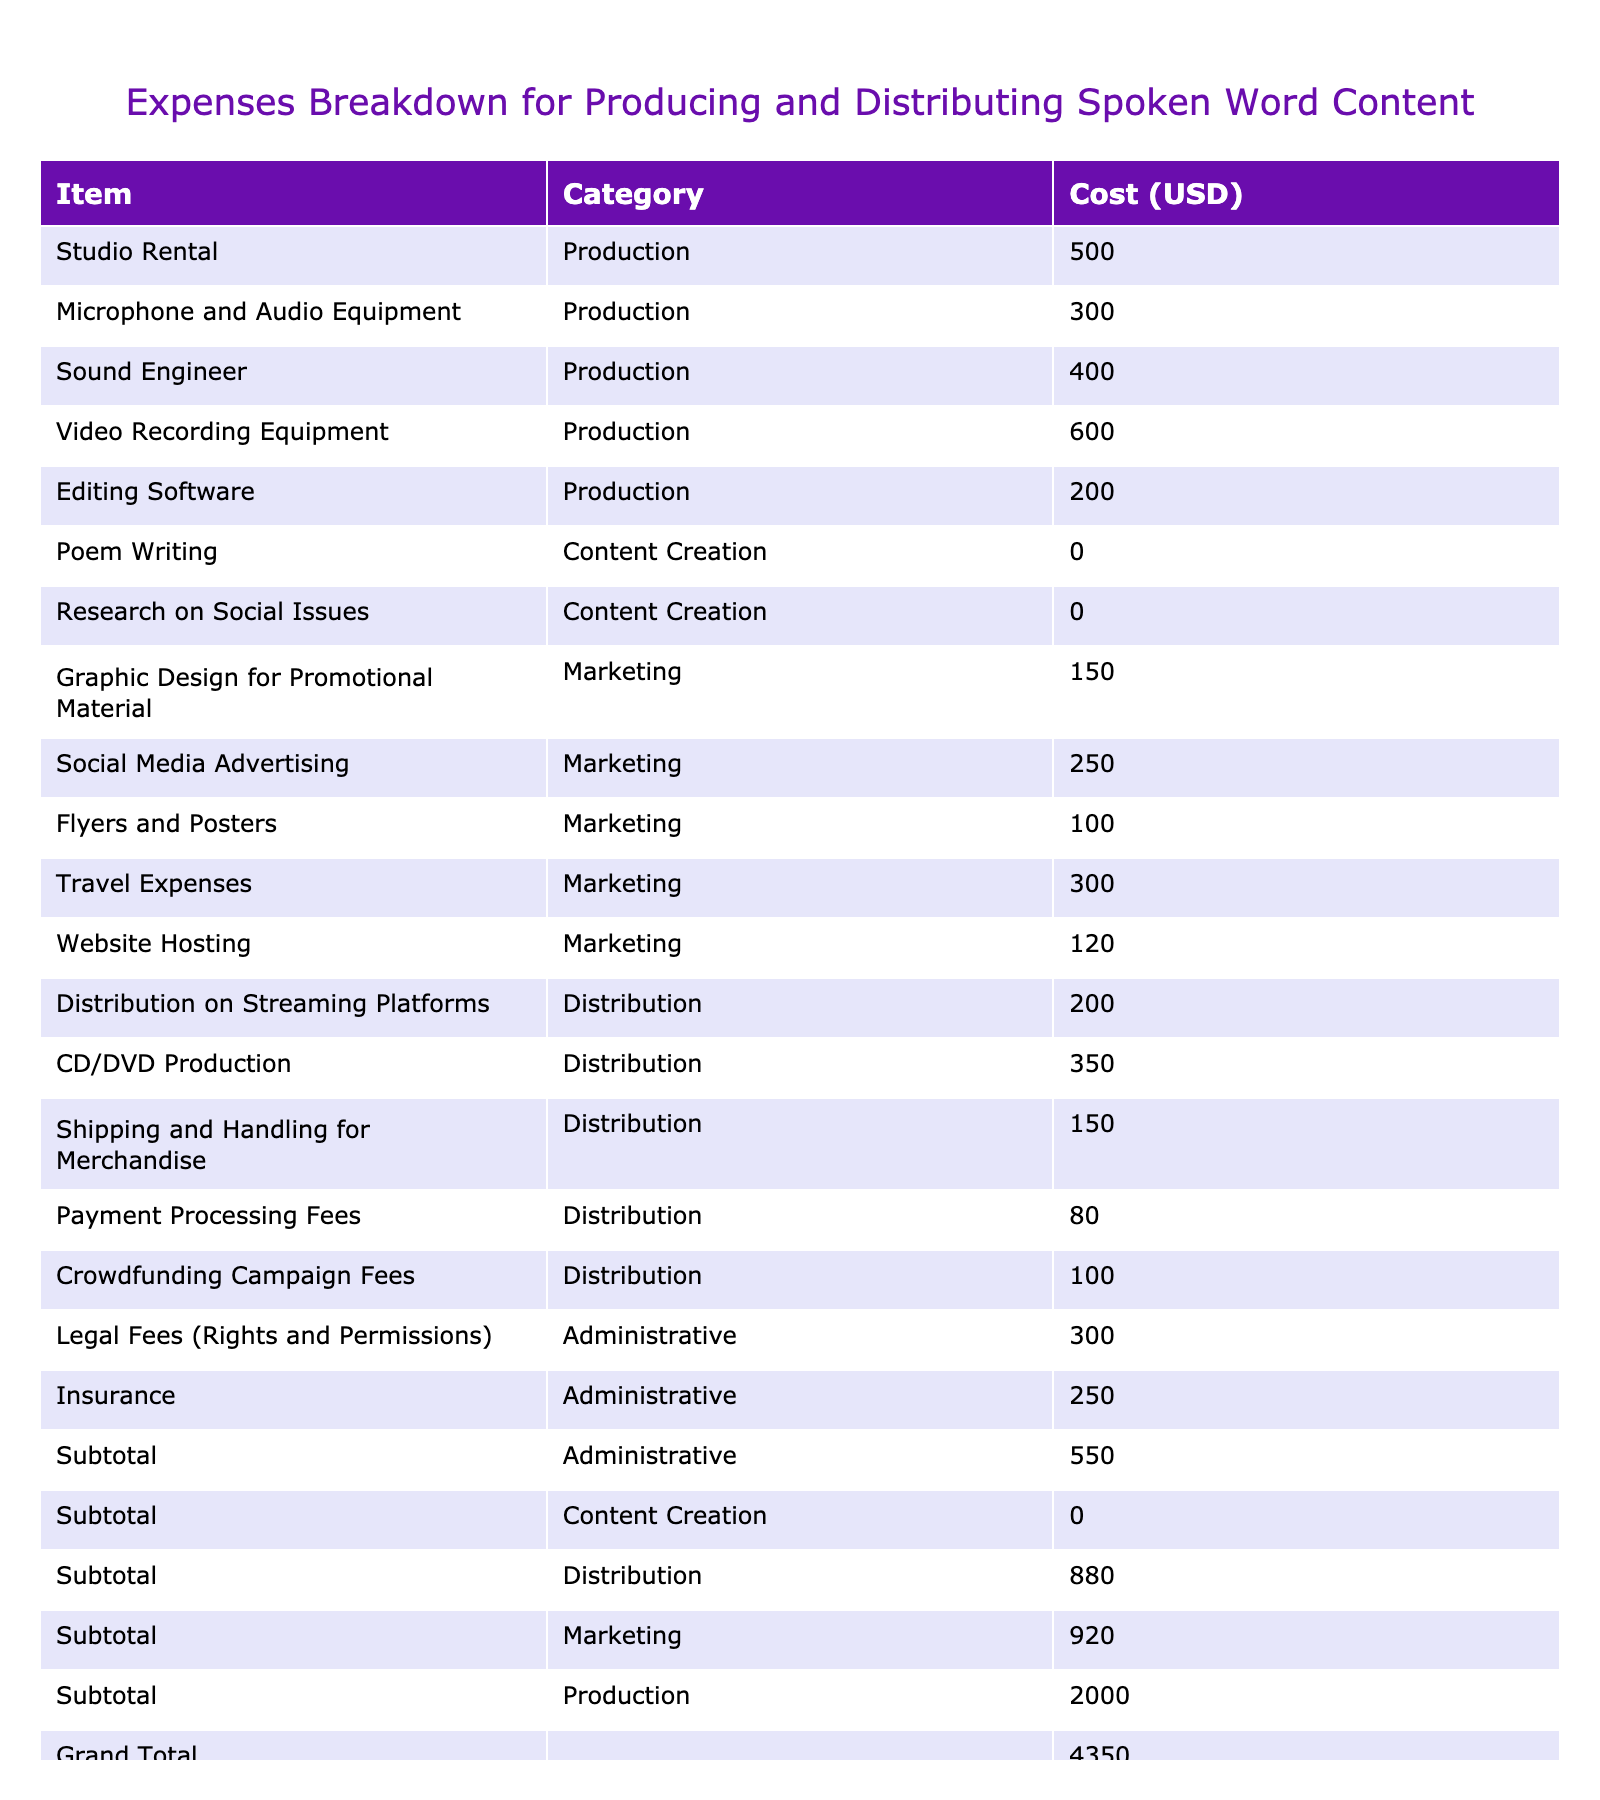What is the total cost for production expenses? To find the total production cost, we add all individual production items: Studio Rental (500) + Microphone and Audio Equipment (300) + Sound Engineer (400) + Video Recording Equipment (600) + Editing Software (200) = 2000.
Answer: 2000 What is the highest individual marketing expense? To identify the highest marketing expense, we look for the maximum value among the marketing items: Graphic Design for Promotional Material (150), Social Media Advertising (250), Flyers and Posters (100), Travel Expenses (300), Website Hosting (120). The highest is Travel Expenses at 300.
Answer: 300 What is the total cost of distribution expenses? To calculate the total distribution expenses, we add the individual distribution items: Distribution on Streaming Platforms (200) + CD/DVD Production (350) + Shipping and Handling for Merchandise (150) + Payment Processing Fees (80) + Crowdfunding Campaign Fees (100) = 980.
Answer: 980 Are the total administrative costs higher than the total production costs? To determine if administrative costs are higher, we find the total administrative costs: Legal Fees (300) + Insurance (250) = 550. The production costs total 2000. Comparing the two, 550 is less than 2000.
Answer: No What is the sum of marketing and administrative expenses? To find the combined total of marketing and administrative expenses, we first calculate each: Marketing total is 150 + 250 + 100 + 300 + 120 = 920; Administrative total is 300 + 250 = 550. The combined sum is 920 + 550 = 1470.
Answer: 1470 How much were the costs for content creation? Content creation includes Poem Writing (0) and Research on Social Issues (0), which sums up to 0.
Answer: 0 What percentage of the total expenses is represented by the production costs? First, we calculate the total expenses: 2000 (production) + 920 (marketing) + 550 (administrative) + 980 (distribution) = 4450. The percentage of production costs is (2000 / 4450) * 100 = about 44.94%.
Answer: 44.94% What is the average cost per category? To find the average cost per category, we need to determine the costs per category and the number of items in each. For production (5 items, total 2000), average is 2000/5 = 400; for marketing (5 items, total 920), average is 920/5 = 184; for distribution (5 items, total 980), average is 980/5 = 196; for administrative (2 items, total 550), average is 550/2 = 275. The results are: Production 400, Marketing 184, Distribution 196, Administrative 275.
Answer: Production: 400, Marketing: 184, Distribution: 196, Administrative: 275 